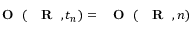Convert formula to latex. <formula><loc_0><loc_0><loc_500><loc_500>{ O } ( { R } , t _ { n } ) = { O } ( { R } , n )</formula> 